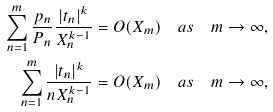<formula> <loc_0><loc_0><loc_500><loc_500>\sum _ { n = 1 } ^ { m } \frac { p _ { n } } { P _ { n } } \frac { | t _ { n } | ^ { k } } { X _ { n } ^ { k - 1 } } & = O ( X _ { m } ) \quad a s \quad m \rightarrow \infty , \\ \sum _ { n = 1 } ^ { m } \frac { | t _ { n } | ^ { k } } { n X _ { n } ^ { k - 1 } } & = O ( X _ { m } ) \quad a s \quad m \rightarrow \infty ,</formula> 